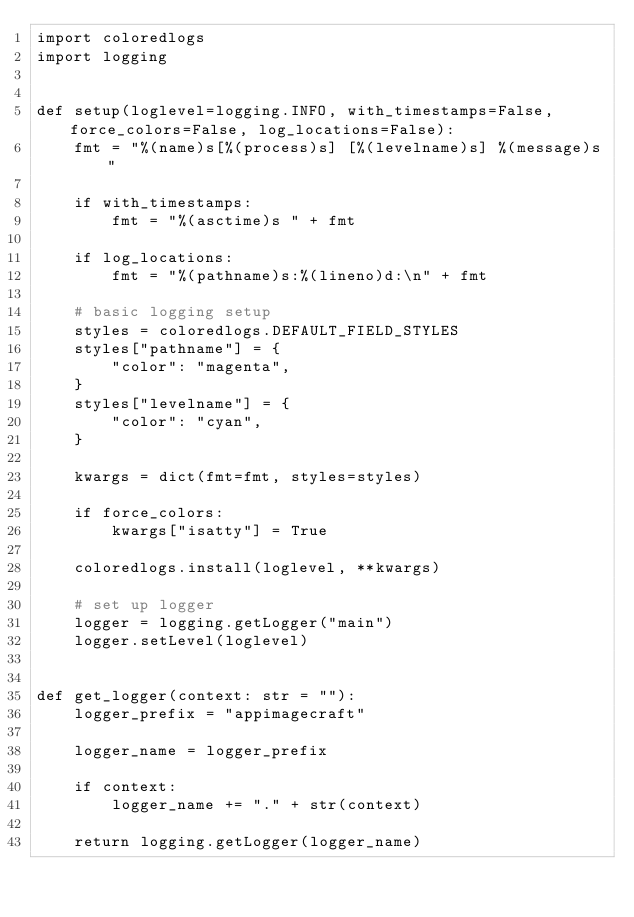Convert code to text. <code><loc_0><loc_0><loc_500><loc_500><_Python_>import coloredlogs
import logging


def setup(loglevel=logging.INFO, with_timestamps=False, force_colors=False, log_locations=False):
    fmt = "%(name)s[%(process)s] [%(levelname)s] %(message)s"

    if with_timestamps:
        fmt = "%(asctime)s " + fmt

    if log_locations:
        fmt = "%(pathname)s:%(lineno)d:\n" + fmt

    # basic logging setup
    styles = coloredlogs.DEFAULT_FIELD_STYLES
    styles["pathname"] = {
        "color": "magenta",
    }
    styles["levelname"] = {
        "color": "cyan",
    }

    kwargs = dict(fmt=fmt, styles=styles)

    if force_colors:
        kwargs["isatty"] = True

    coloredlogs.install(loglevel, **kwargs)

    # set up logger
    logger = logging.getLogger("main")
    logger.setLevel(loglevel)


def get_logger(context: str = ""):
    logger_prefix = "appimagecraft"

    logger_name = logger_prefix

    if context:
        logger_name += "." + str(context)

    return logging.getLogger(logger_name)
</code> 